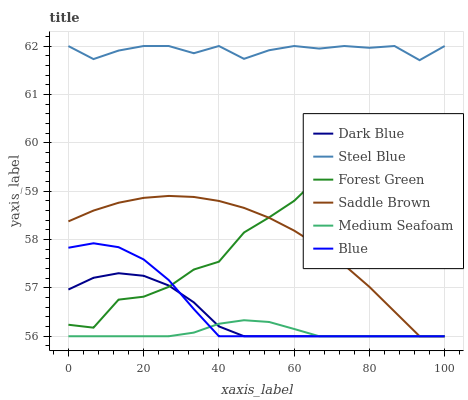Does Medium Seafoam have the minimum area under the curve?
Answer yes or no. Yes. Does Steel Blue have the maximum area under the curve?
Answer yes or no. Yes. Does Saddle Brown have the minimum area under the curve?
Answer yes or no. No. Does Saddle Brown have the maximum area under the curve?
Answer yes or no. No. Is Medium Seafoam the smoothest?
Answer yes or no. Yes. Is Forest Green the roughest?
Answer yes or no. Yes. Is Steel Blue the smoothest?
Answer yes or no. No. Is Steel Blue the roughest?
Answer yes or no. No. Does Blue have the lowest value?
Answer yes or no. Yes. Does Steel Blue have the lowest value?
Answer yes or no. No. Does Steel Blue have the highest value?
Answer yes or no. Yes. Does Saddle Brown have the highest value?
Answer yes or no. No. Is Forest Green less than Steel Blue?
Answer yes or no. Yes. Is Forest Green greater than Medium Seafoam?
Answer yes or no. Yes. Does Medium Seafoam intersect Blue?
Answer yes or no. Yes. Is Medium Seafoam less than Blue?
Answer yes or no. No. Is Medium Seafoam greater than Blue?
Answer yes or no. No. Does Forest Green intersect Steel Blue?
Answer yes or no. No. 